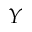Convert formula to latex. <formula><loc_0><loc_0><loc_500><loc_500>Y</formula> 